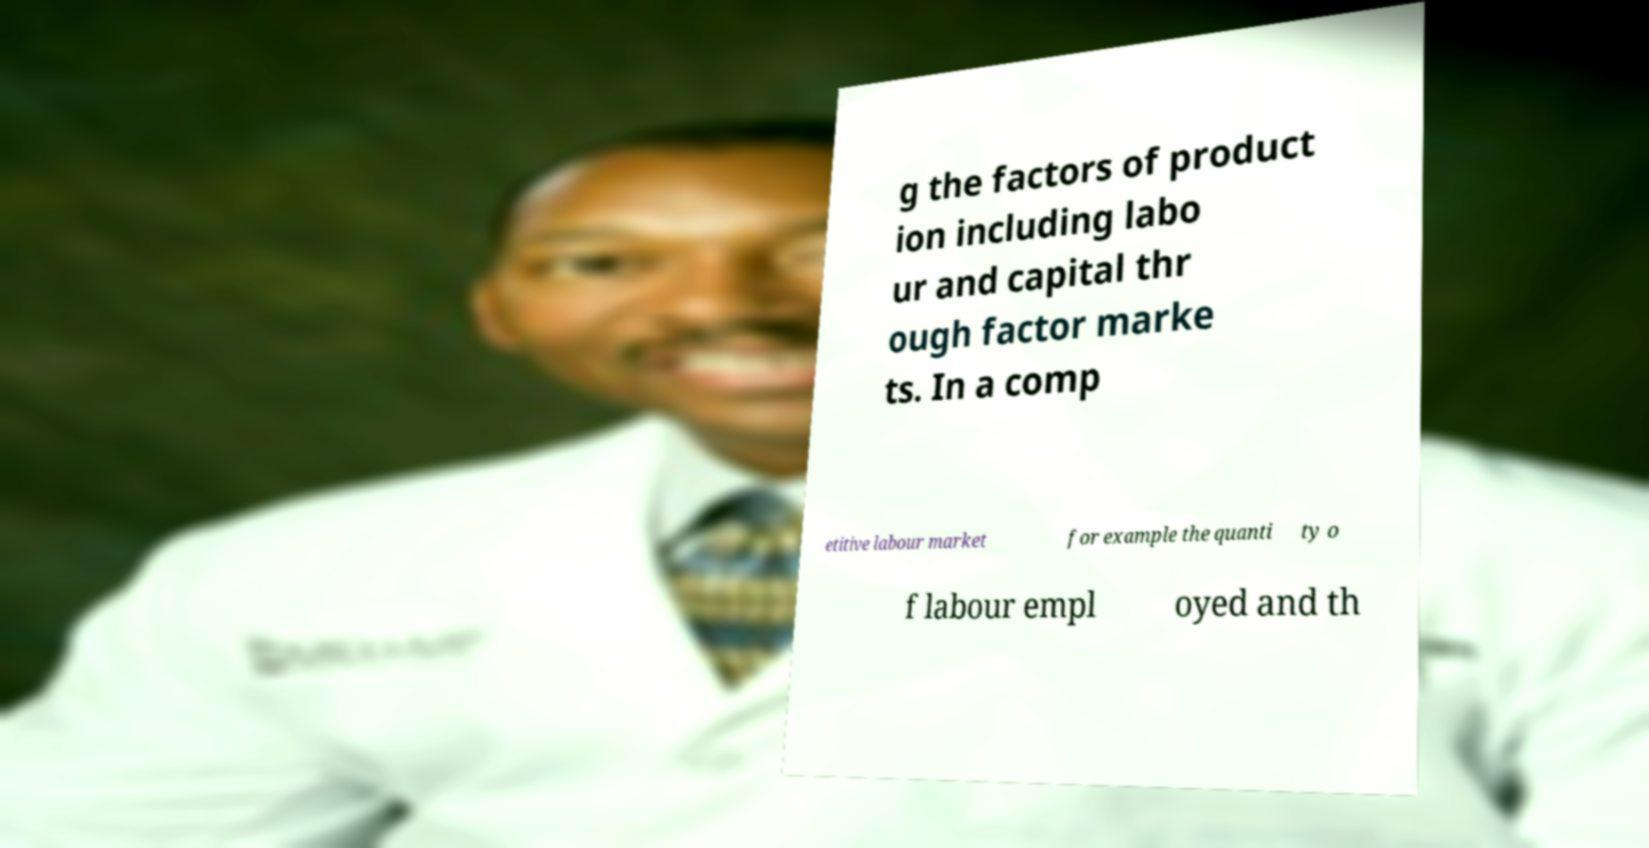I need the written content from this picture converted into text. Can you do that? g the factors of product ion including labo ur and capital thr ough factor marke ts. In a comp etitive labour market for example the quanti ty o f labour empl oyed and th 